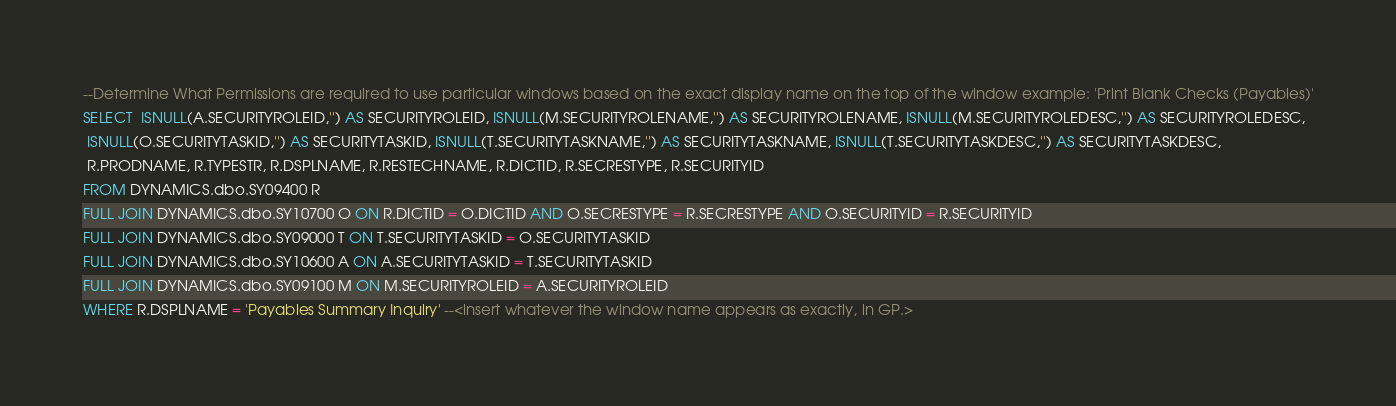<code> <loc_0><loc_0><loc_500><loc_500><_SQL_>
--Determine What Permissions are required to use particular windows based on the exact display name on the top of the window example: 'Print Blank Checks (Payables)'
SELECT  ISNULL(A.SECURITYROLEID,'') AS SECURITYROLEID, ISNULL(M.SECURITYROLENAME,'') AS SECURITYROLENAME, ISNULL(M.SECURITYROLEDESC,'') AS SECURITYROLEDESC,
 ISNULL(O.SECURITYTASKID,'') AS SECURITYTASKID, ISNULL(T.SECURITYTASKNAME,'') AS SECURITYTASKNAME, ISNULL(T.SECURITYTASKDESC,'') AS SECURITYTASKDESC, 
 R.PRODNAME, R.TYPESTR, R.DSPLNAME, R.RESTECHNAME, R.DICTID, R.SECRESTYPE, R.SECURITYID
FROM DYNAMICS.dbo.SY09400 R
FULL JOIN DYNAMICS.dbo.SY10700 O ON R.DICTID = O.DICTID AND O.SECRESTYPE = R.SECRESTYPE AND O.SECURITYID = R.SECURITYID
FULL JOIN DYNAMICS.dbo.SY09000 T ON T.SECURITYTASKID = O.SECURITYTASKID
FULL JOIN DYNAMICS.dbo.SY10600 A ON A.SECURITYTASKID = T.SECURITYTASKID
FULL JOIN DYNAMICS.dbo.SY09100 M ON M.SECURITYROLEID = A.SECURITYROLEID
WHERE R.DSPLNAME = 'Payables Summary Inquiry' --<insert whatever the window name appears as exactly, in GP.>
</code> 